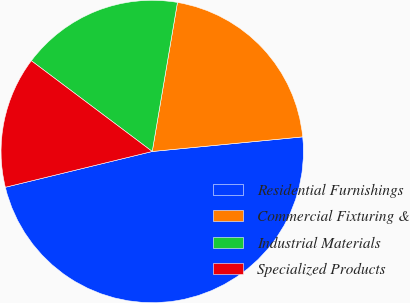Convert chart. <chart><loc_0><loc_0><loc_500><loc_500><pie_chart><fcel>Residential Furnishings<fcel>Commercial Fixturing &<fcel>Industrial Materials<fcel>Specialized Products<nl><fcel>47.74%<fcel>20.79%<fcel>17.42%<fcel>14.05%<nl></chart> 